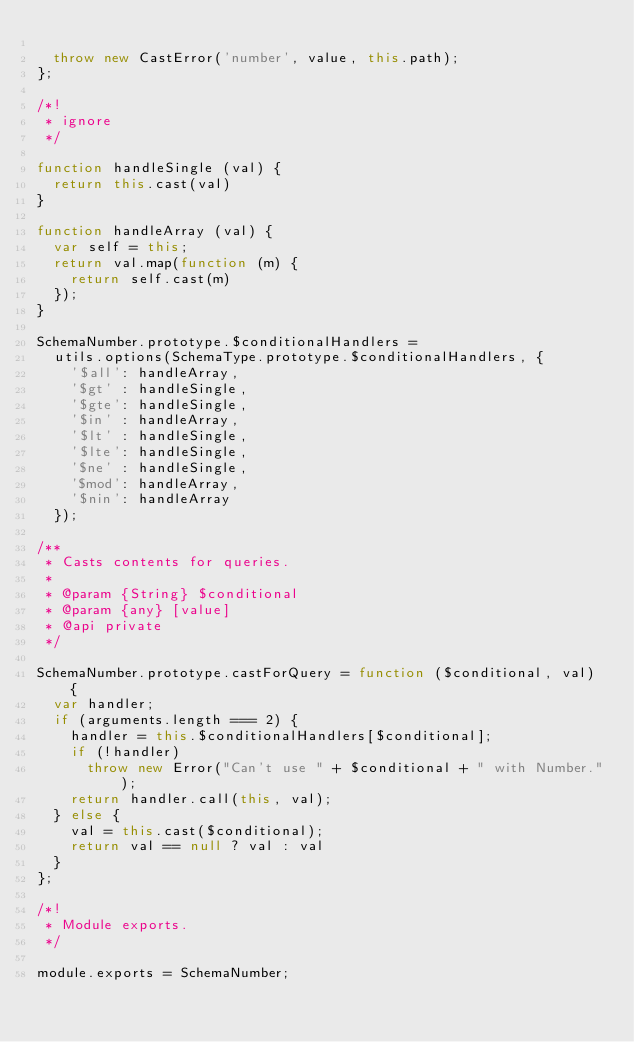Convert code to text. <code><loc_0><loc_0><loc_500><loc_500><_JavaScript_>
  throw new CastError('number', value, this.path);
};

/*!
 * ignore
 */

function handleSingle (val) {
  return this.cast(val)
}

function handleArray (val) {
  var self = this;
  return val.map(function (m) {
    return self.cast(m)
  });
}

SchemaNumber.prototype.$conditionalHandlers =
  utils.options(SchemaType.prototype.$conditionalHandlers, {
    '$all': handleArray,
    '$gt' : handleSingle,
    '$gte': handleSingle,
    '$in' : handleArray,
    '$lt' : handleSingle,
    '$lte': handleSingle,
    '$ne' : handleSingle,
    '$mod': handleArray,
    '$nin': handleArray
  });

/**
 * Casts contents for queries.
 *
 * @param {String} $conditional
 * @param {any} [value]
 * @api private
 */

SchemaNumber.prototype.castForQuery = function ($conditional, val) {
  var handler;
  if (arguments.length === 2) {
    handler = this.$conditionalHandlers[$conditional];
    if (!handler)
      throw new Error("Can't use " + $conditional + " with Number.");
    return handler.call(this, val);
  } else {
    val = this.cast($conditional);
    return val == null ? val : val
  }
};

/*!
 * Module exports.
 */

module.exports = SchemaNumber;
</code> 